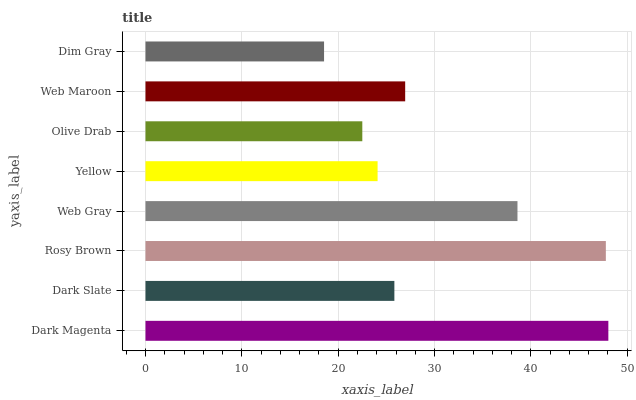Is Dim Gray the minimum?
Answer yes or no. Yes. Is Dark Magenta the maximum?
Answer yes or no. Yes. Is Dark Slate the minimum?
Answer yes or no. No. Is Dark Slate the maximum?
Answer yes or no. No. Is Dark Magenta greater than Dark Slate?
Answer yes or no. Yes. Is Dark Slate less than Dark Magenta?
Answer yes or no. Yes. Is Dark Slate greater than Dark Magenta?
Answer yes or no. No. Is Dark Magenta less than Dark Slate?
Answer yes or no. No. Is Web Maroon the high median?
Answer yes or no. Yes. Is Dark Slate the low median?
Answer yes or no. Yes. Is Yellow the high median?
Answer yes or no. No. Is Yellow the low median?
Answer yes or no. No. 